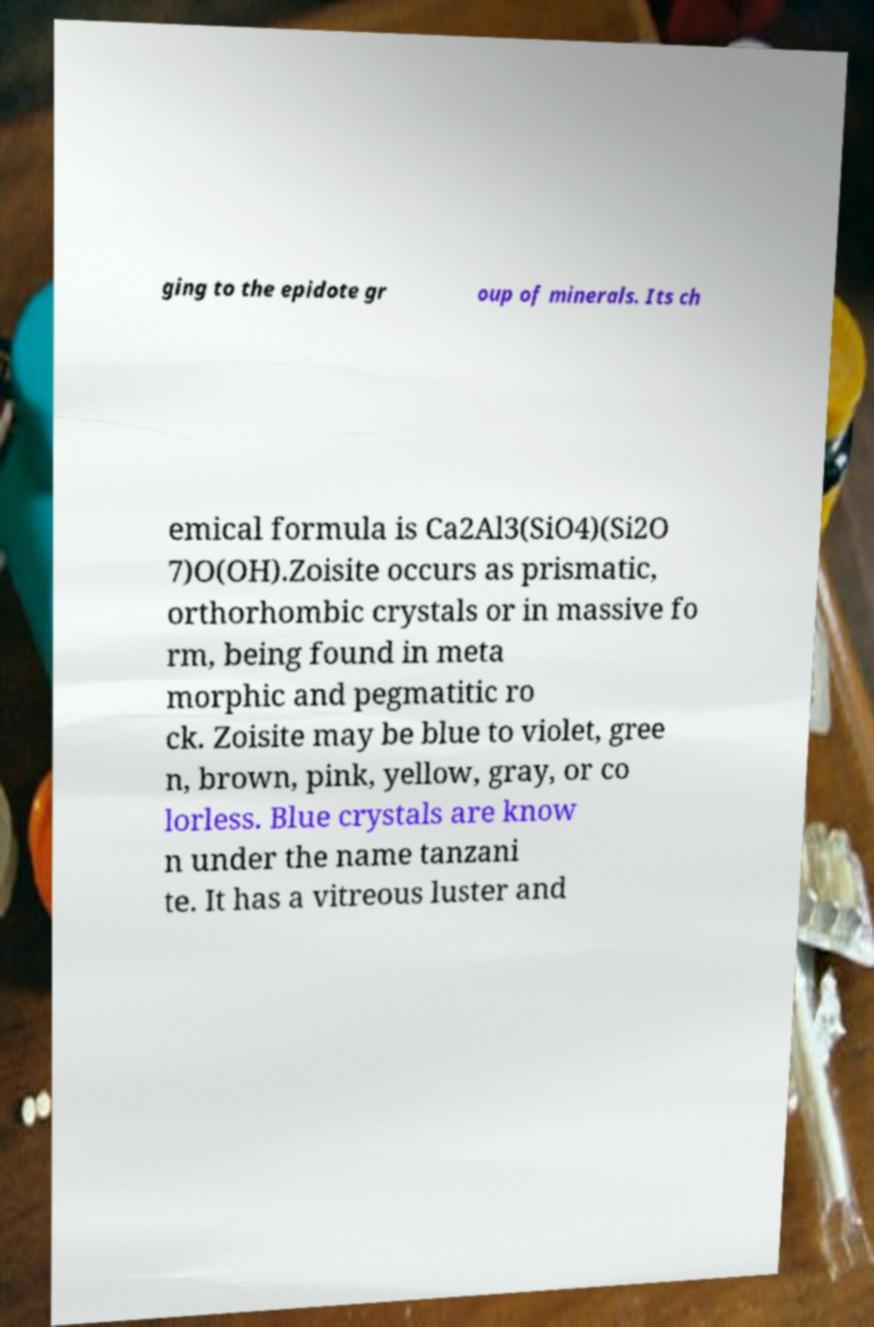There's text embedded in this image that I need extracted. Can you transcribe it verbatim? ging to the epidote gr oup of minerals. Its ch emical formula is Ca2Al3(SiO4)(Si2O 7)O(OH).Zoisite occurs as prismatic, orthorhombic crystals or in massive fo rm, being found in meta morphic and pegmatitic ro ck. Zoisite may be blue to violet, gree n, brown, pink, yellow, gray, or co lorless. Blue crystals are know n under the name tanzani te. It has a vitreous luster and 